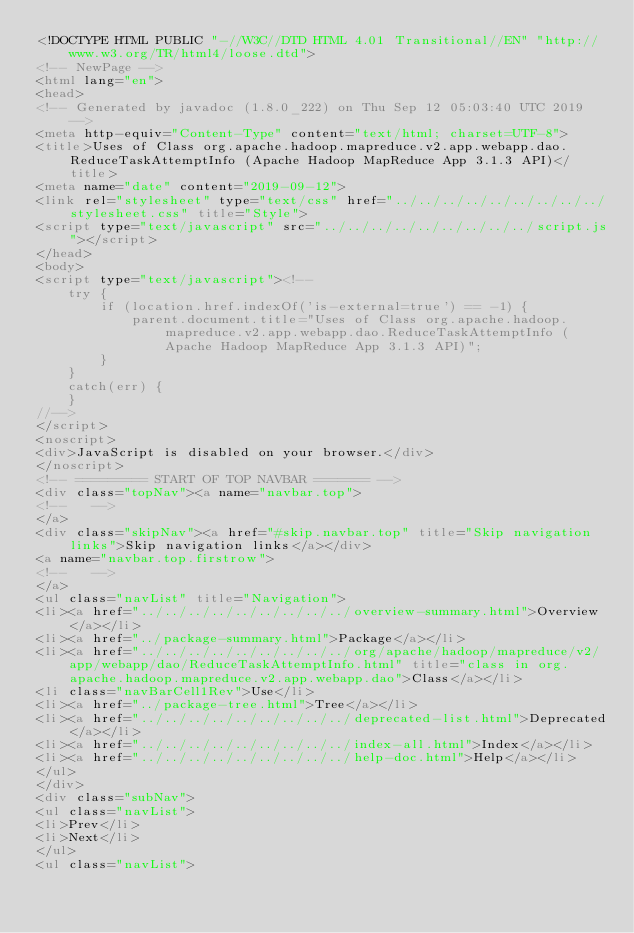Convert code to text. <code><loc_0><loc_0><loc_500><loc_500><_HTML_><!DOCTYPE HTML PUBLIC "-//W3C//DTD HTML 4.01 Transitional//EN" "http://www.w3.org/TR/html4/loose.dtd">
<!-- NewPage -->
<html lang="en">
<head>
<!-- Generated by javadoc (1.8.0_222) on Thu Sep 12 05:03:40 UTC 2019 -->
<meta http-equiv="Content-Type" content="text/html; charset=UTF-8">
<title>Uses of Class org.apache.hadoop.mapreduce.v2.app.webapp.dao.ReduceTaskAttemptInfo (Apache Hadoop MapReduce App 3.1.3 API)</title>
<meta name="date" content="2019-09-12">
<link rel="stylesheet" type="text/css" href="../../../../../../../../../stylesheet.css" title="Style">
<script type="text/javascript" src="../../../../../../../../../script.js"></script>
</head>
<body>
<script type="text/javascript"><!--
    try {
        if (location.href.indexOf('is-external=true') == -1) {
            parent.document.title="Uses of Class org.apache.hadoop.mapreduce.v2.app.webapp.dao.ReduceTaskAttemptInfo (Apache Hadoop MapReduce App 3.1.3 API)";
        }
    }
    catch(err) {
    }
//-->
</script>
<noscript>
<div>JavaScript is disabled on your browser.</div>
</noscript>
<!-- ========= START OF TOP NAVBAR ======= -->
<div class="topNav"><a name="navbar.top">
<!--   -->
</a>
<div class="skipNav"><a href="#skip.navbar.top" title="Skip navigation links">Skip navigation links</a></div>
<a name="navbar.top.firstrow">
<!--   -->
</a>
<ul class="navList" title="Navigation">
<li><a href="../../../../../../../../../overview-summary.html">Overview</a></li>
<li><a href="../package-summary.html">Package</a></li>
<li><a href="../../../../../../../../../org/apache/hadoop/mapreduce/v2/app/webapp/dao/ReduceTaskAttemptInfo.html" title="class in org.apache.hadoop.mapreduce.v2.app.webapp.dao">Class</a></li>
<li class="navBarCell1Rev">Use</li>
<li><a href="../package-tree.html">Tree</a></li>
<li><a href="../../../../../../../../../deprecated-list.html">Deprecated</a></li>
<li><a href="../../../../../../../../../index-all.html">Index</a></li>
<li><a href="../../../../../../../../../help-doc.html">Help</a></li>
</ul>
</div>
<div class="subNav">
<ul class="navList">
<li>Prev</li>
<li>Next</li>
</ul>
<ul class="navList"></code> 